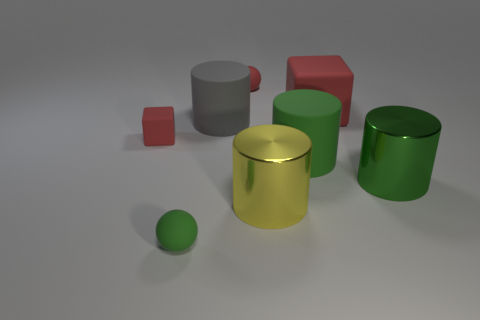There is a matte thing that is in front of the matte cylinder that is right of the small red ball behind the large gray rubber object; what size is it?
Keep it short and to the point. Small. Are there more small gray blocks than red rubber cubes?
Your answer should be very brief. No. Is the material of the object that is right of the large red rubber object the same as the tiny green ball?
Provide a succinct answer. No. Are there fewer tiny brown matte spheres than big green metal objects?
Offer a terse response. Yes. There is a large gray thing that is on the left side of the large matte cylinder right of the yellow metal cylinder; are there any red balls in front of it?
Offer a very short reply. No. Is the shape of the big matte thing that is behind the large gray thing the same as  the big gray thing?
Make the answer very short. No. Is the number of big gray rubber objects that are in front of the green shiny object greater than the number of small matte blocks?
Keep it short and to the point. No. There is a rubber sphere that is behind the green matte ball; is its color the same as the large block?
Give a very brief answer. Yes. Are there any other things of the same color as the tiny matte cube?
Your response must be concise. Yes. There is a small ball to the right of the green matte object left of the red matte object behind the big block; what is its color?
Provide a short and direct response. Red. 